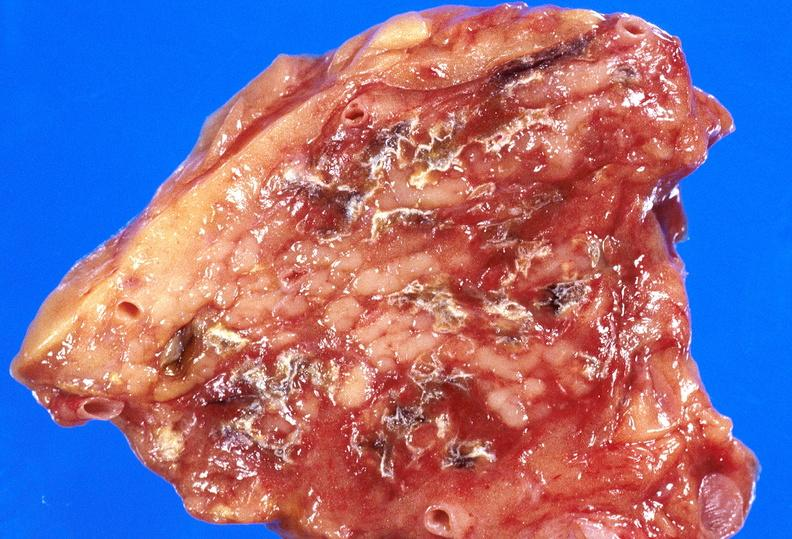does this image show pancreatic fat necrosis?
Answer the question using a single word or phrase. Yes 